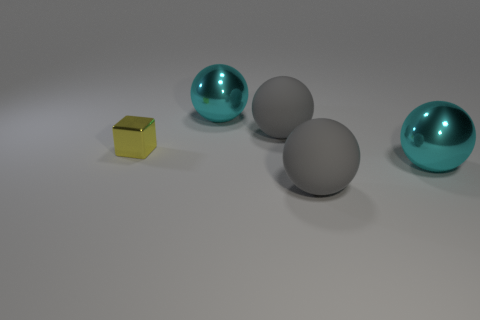Add 5 large gray balls. How many objects exist? 10 Subtract all brown spheres. Subtract all green blocks. How many spheres are left? 4 Subtract all cubes. How many objects are left? 4 Add 4 small cyan metal cylinders. How many small cyan metal cylinders exist? 4 Subtract 0 green balls. How many objects are left? 5 Subtract all small cyan rubber cylinders. Subtract all small metal things. How many objects are left? 4 Add 1 cyan spheres. How many cyan spheres are left? 3 